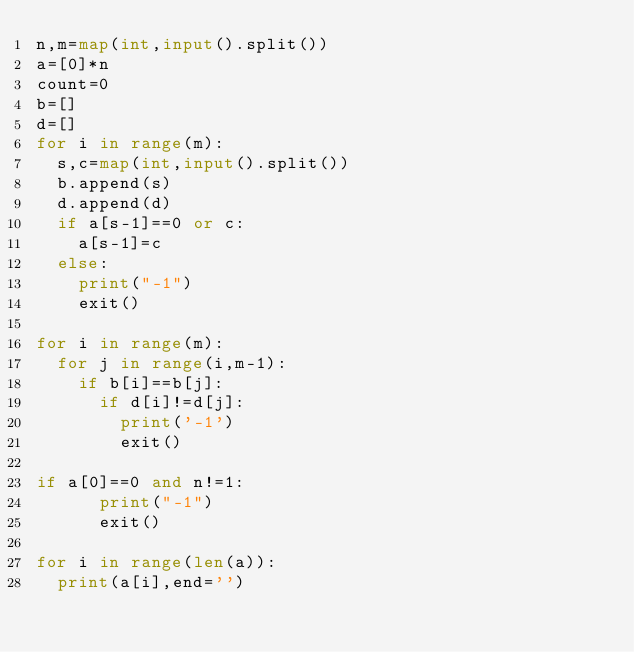<code> <loc_0><loc_0><loc_500><loc_500><_Python_>n,m=map(int,input().split())
a=[0]*n
count=0
b=[]
d=[]
for i in range(m):
  s,c=map(int,input().split())
  b.append(s)
  d.append(d)
  if a[s-1]==0 or c:
    a[s-1]=c  
  else:
    print("-1")
    exit()
    
for i in range(m):
  for j in range(i,m-1):
    if b[i]==b[j]:
      if d[i]!=d[j]:
        print('-1')
        exit()
  
if a[0]==0 and n!=1:
      print("-1")
      exit()
      
for i in range(len(a)):
  print(a[i],end='')</code> 